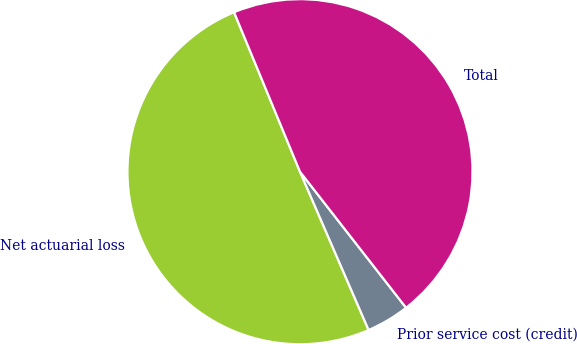Convert chart. <chart><loc_0><loc_0><loc_500><loc_500><pie_chart><fcel>Net actuarial loss<fcel>Prior service cost (credit)<fcel>Total<nl><fcel>50.27%<fcel>4.03%<fcel>45.7%<nl></chart> 